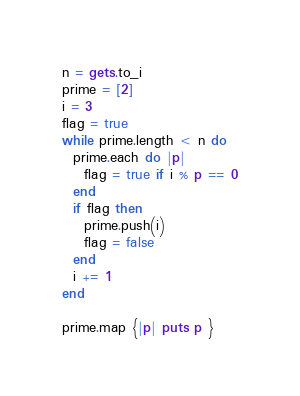Convert code to text. <code><loc_0><loc_0><loc_500><loc_500><_Ruby_>n = gets.to_i
prime = [2]
i = 3
flag = true
while prime.length < n do
  prime.each do |p|
    flag = true if i % p == 0
  end
  if flag then 
    prime.push(i)
    flag = false
  end
  i += 1
end

prime.map {|p| puts p }</code> 